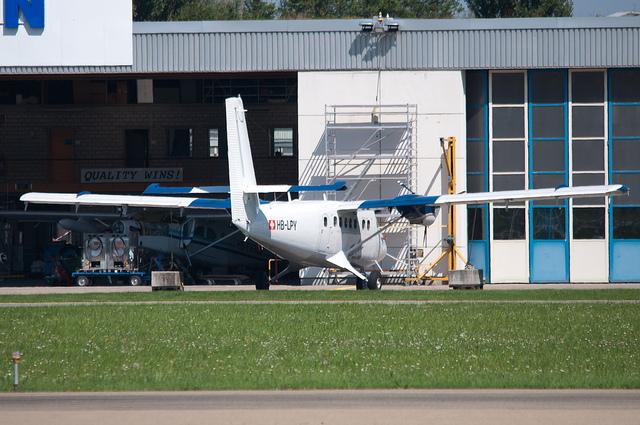What color is the plane?
Give a very brief answer. White. Is this plane bigger or smaller than a 747?
Quick response, please. Smaller. What is the purpose for this plane?
Give a very brief answer. Transportation. 